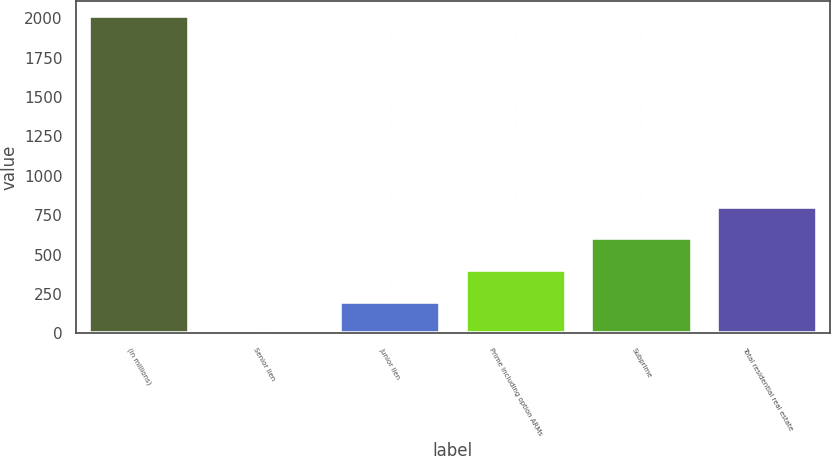<chart> <loc_0><loc_0><loc_500><loc_500><bar_chart><fcel>(in millions)<fcel>Senior lien<fcel>Junior lien<fcel>Prime including option ARMs<fcel>Subprime<fcel>Total residential real estate<nl><fcel>2011<fcel>1<fcel>202<fcel>403<fcel>604<fcel>805<nl></chart> 